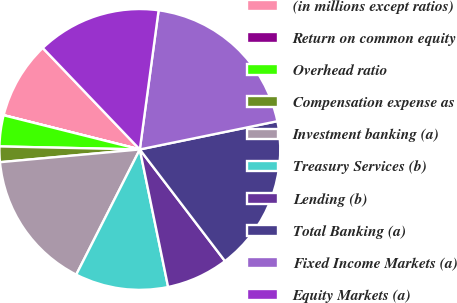<chart> <loc_0><loc_0><loc_500><loc_500><pie_chart><fcel>(in millions except ratios)<fcel>Return on common equity<fcel>Overhead ratio<fcel>Compensation expense as<fcel>Investment banking (a)<fcel>Treasury Services (b)<fcel>Lending (b)<fcel>Total Banking (a)<fcel>Fixed Income Markets (a)<fcel>Equity Markets (a)<nl><fcel>8.93%<fcel>0.01%<fcel>3.57%<fcel>1.79%<fcel>16.07%<fcel>10.71%<fcel>7.14%<fcel>17.85%<fcel>19.64%<fcel>14.28%<nl></chart> 